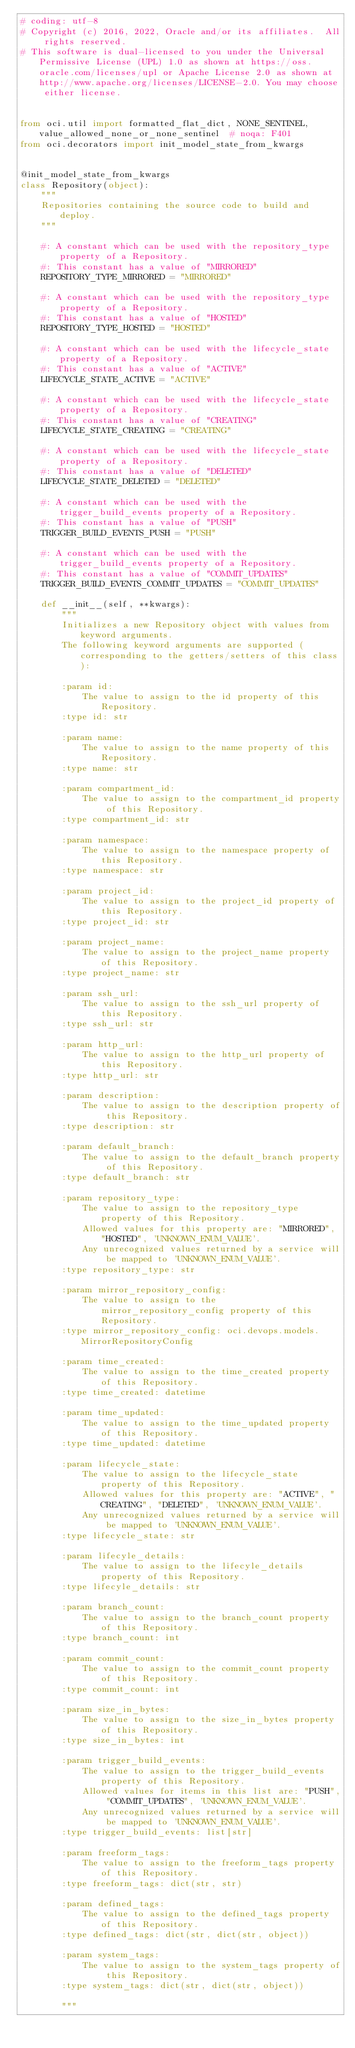Convert code to text. <code><loc_0><loc_0><loc_500><loc_500><_Python_># coding: utf-8
# Copyright (c) 2016, 2022, Oracle and/or its affiliates.  All rights reserved.
# This software is dual-licensed to you under the Universal Permissive License (UPL) 1.0 as shown at https://oss.oracle.com/licenses/upl or Apache License 2.0 as shown at http://www.apache.org/licenses/LICENSE-2.0. You may choose either license.


from oci.util import formatted_flat_dict, NONE_SENTINEL, value_allowed_none_or_none_sentinel  # noqa: F401
from oci.decorators import init_model_state_from_kwargs


@init_model_state_from_kwargs
class Repository(object):
    """
    Repositories containing the source code to build and deploy.
    """

    #: A constant which can be used with the repository_type property of a Repository.
    #: This constant has a value of "MIRRORED"
    REPOSITORY_TYPE_MIRRORED = "MIRRORED"

    #: A constant which can be used with the repository_type property of a Repository.
    #: This constant has a value of "HOSTED"
    REPOSITORY_TYPE_HOSTED = "HOSTED"

    #: A constant which can be used with the lifecycle_state property of a Repository.
    #: This constant has a value of "ACTIVE"
    LIFECYCLE_STATE_ACTIVE = "ACTIVE"

    #: A constant which can be used with the lifecycle_state property of a Repository.
    #: This constant has a value of "CREATING"
    LIFECYCLE_STATE_CREATING = "CREATING"

    #: A constant which can be used with the lifecycle_state property of a Repository.
    #: This constant has a value of "DELETED"
    LIFECYCLE_STATE_DELETED = "DELETED"

    #: A constant which can be used with the trigger_build_events property of a Repository.
    #: This constant has a value of "PUSH"
    TRIGGER_BUILD_EVENTS_PUSH = "PUSH"

    #: A constant which can be used with the trigger_build_events property of a Repository.
    #: This constant has a value of "COMMIT_UPDATES"
    TRIGGER_BUILD_EVENTS_COMMIT_UPDATES = "COMMIT_UPDATES"

    def __init__(self, **kwargs):
        """
        Initializes a new Repository object with values from keyword arguments.
        The following keyword arguments are supported (corresponding to the getters/setters of this class):

        :param id:
            The value to assign to the id property of this Repository.
        :type id: str

        :param name:
            The value to assign to the name property of this Repository.
        :type name: str

        :param compartment_id:
            The value to assign to the compartment_id property of this Repository.
        :type compartment_id: str

        :param namespace:
            The value to assign to the namespace property of this Repository.
        :type namespace: str

        :param project_id:
            The value to assign to the project_id property of this Repository.
        :type project_id: str

        :param project_name:
            The value to assign to the project_name property of this Repository.
        :type project_name: str

        :param ssh_url:
            The value to assign to the ssh_url property of this Repository.
        :type ssh_url: str

        :param http_url:
            The value to assign to the http_url property of this Repository.
        :type http_url: str

        :param description:
            The value to assign to the description property of this Repository.
        :type description: str

        :param default_branch:
            The value to assign to the default_branch property of this Repository.
        :type default_branch: str

        :param repository_type:
            The value to assign to the repository_type property of this Repository.
            Allowed values for this property are: "MIRRORED", "HOSTED", 'UNKNOWN_ENUM_VALUE'.
            Any unrecognized values returned by a service will be mapped to 'UNKNOWN_ENUM_VALUE'.
        :type repository_type: str

        :param mirror_repository_config:
            The value to assign to the mirror_repository_config property of this Repository.
        :type mirror_repository_config: oci.devops.models.MirrorRepositoryConfig

        :param time_created:
            The value to assign to the time_created property of this Repository.
        :type time_created: datetime

        :param time_updated:
            The value to assign to the time_updated property of this Repository.
        :type time_updated: datetime

        :param lifecycle_state:
            The value to assign to the lifecycle_state property of this Repository.
            Allowed values for this property are: "ACTIVE", "CREATING", "DELETED", 'UNKNOWN_ENUM_VALUE'.
            Any unrecognized values returned by a service will be mapped to 'UNKNOWN_ENUM_VALUE'.
        :type lifecycle_state: str

        :param lifecyle_details:
            The value to assign to the lifecyle_details property of this Repository.
        :type lifecyle_details: str

        :param branch_count:
            The value to assign to the branch_count property of this Repository.
        :type branch_count: int

        :param commit_count:
            The value to assign to the commit_count property of this Repository.
        :type commit_count: int

        :param size_in_bytes:
            The value to assign to the size_in_bytes property of this Repository.
        :type size_in_bytes: int

        :param trigger_build_events:
            The value to assign to the trigger_build_events property of this Repository.
            Allowed values for items in this list are: "PUSH", "COMMIT_UPDATES", 'UNKNOWN_ENUM_VALUE'.
            Any unrecognized values returned by a service will be mapped to 'UNKNOWN_ENUM_VALUE'.
        :type trigger_build_events: list[str]

        :param freeform_tags:
            The value to assign to the freeform_tags property of this Repository.
        :type freeform_tags: dict(str, str)

        :param defined_tags:
            The value to assign to the defined_tags property of this Repository.
        :type defined_tags: dict(str, dict(str, object))

        :param system_tags:
            The value to assign to the system_tags property of this Repository.
        :type system_tags: dict(str, dict(str, object))

        """</code> 